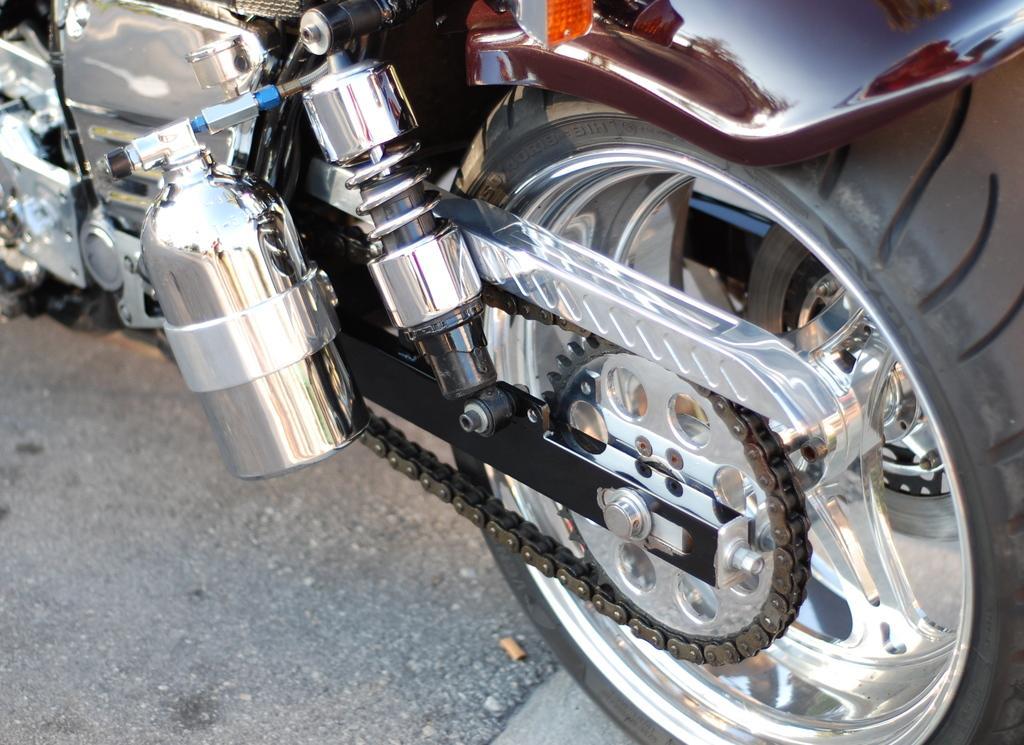In one or two sentences, can you explain what this image depicts? In this image I can see a wheel, a chain socket and few other things of a vehicle. I can see this image is truncated picture of a vehicle. 